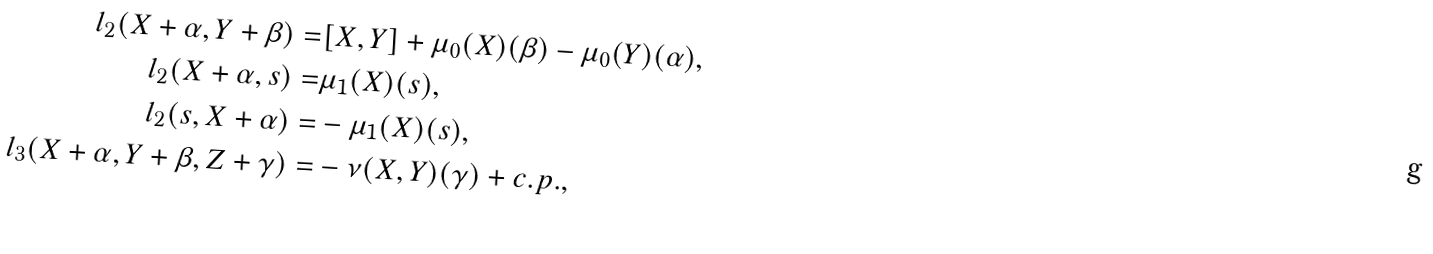<formula> <loc_0><loc_0><loc_500><loc_500>l _ { 2 } ( X + \alpha , Y + \beta ) = & [ X , Y ] + \mu _ { 0 } ( X ) ( \beta ) - \mu _ { 0 } ( Y ) ( \alpha ) , \\ l _ { 2 } ( X + \alpha , s ) = & \mu _ { 1 } ( X ) ( s ) , \\ l _ { 2 } ( s , X + \alpha ) = & - \mu _ { 1 } ( X ) ( s ) , \\ l _ { 3 } ( X + \alpha , Y + \beta , Z + \gamma ) = & - \nu ( X , Y ) ( \gamma ) + c . p . ,</formula> 